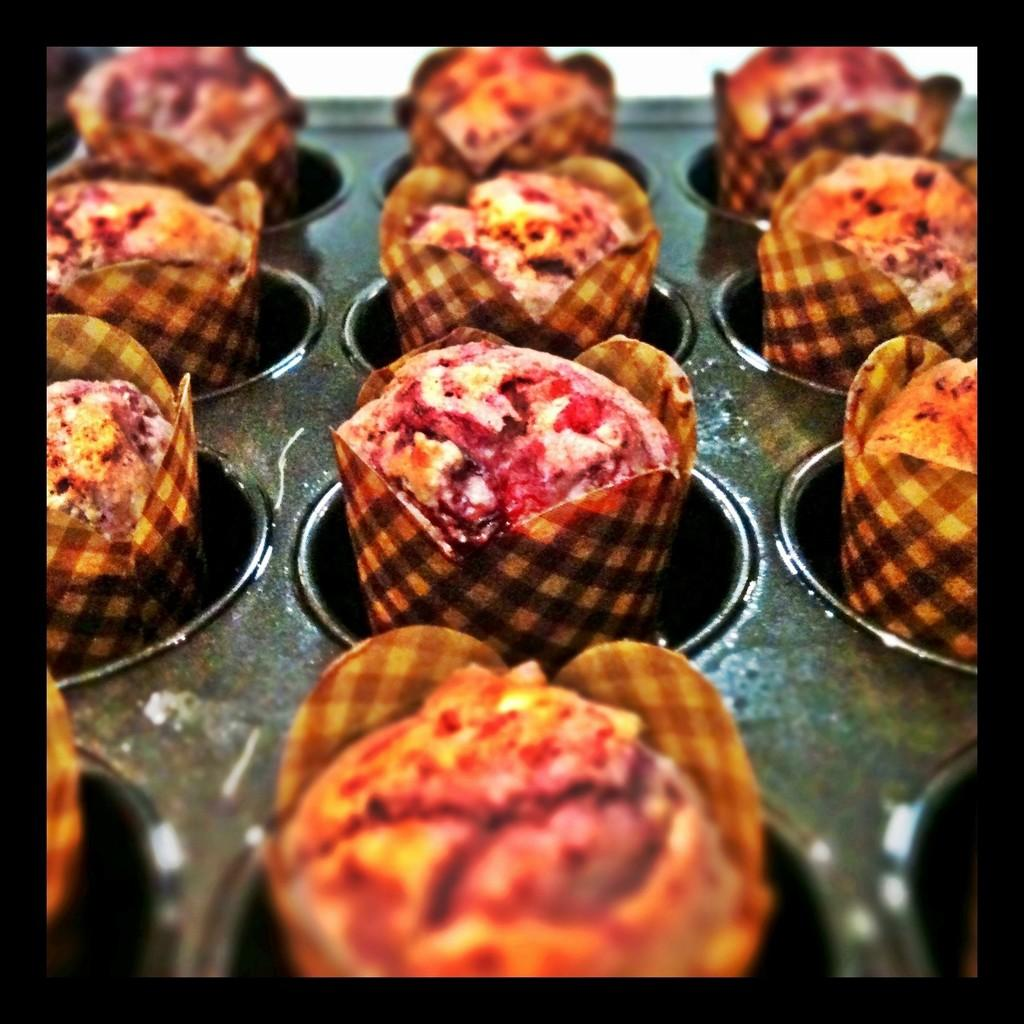What type of food is visible in the image? The food appears to be cupcakes in the image. Can you describe the colors of the cupcakes? The cupcakes have brown and red colors. Are there any bells hanging from the cupcakes in the image? There are no bells present in the image; it only features cupcakes with brown and red colors. 